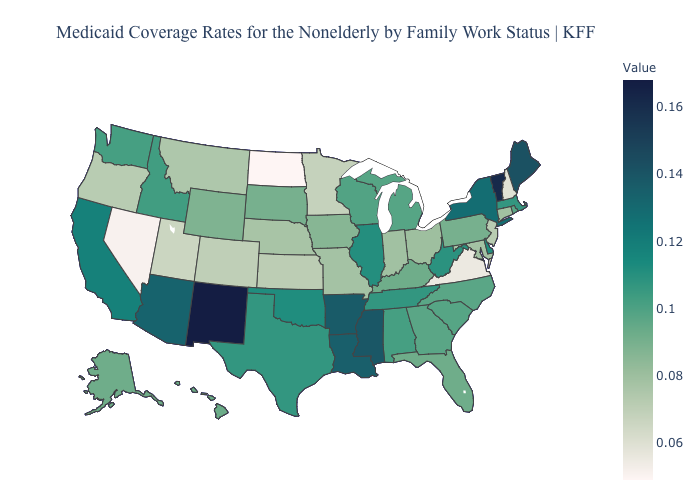Which states hav the highest value in the Northeast?
Concise answer only. Vermont. Among the states that border Indiana , which have the lowest value?
Short answer required. Ohio. Does New York have the highest value in the Northeast?
Short answer required. No. Does West Virginia have a lower value than Maine?
Keep it brief. Yes. 